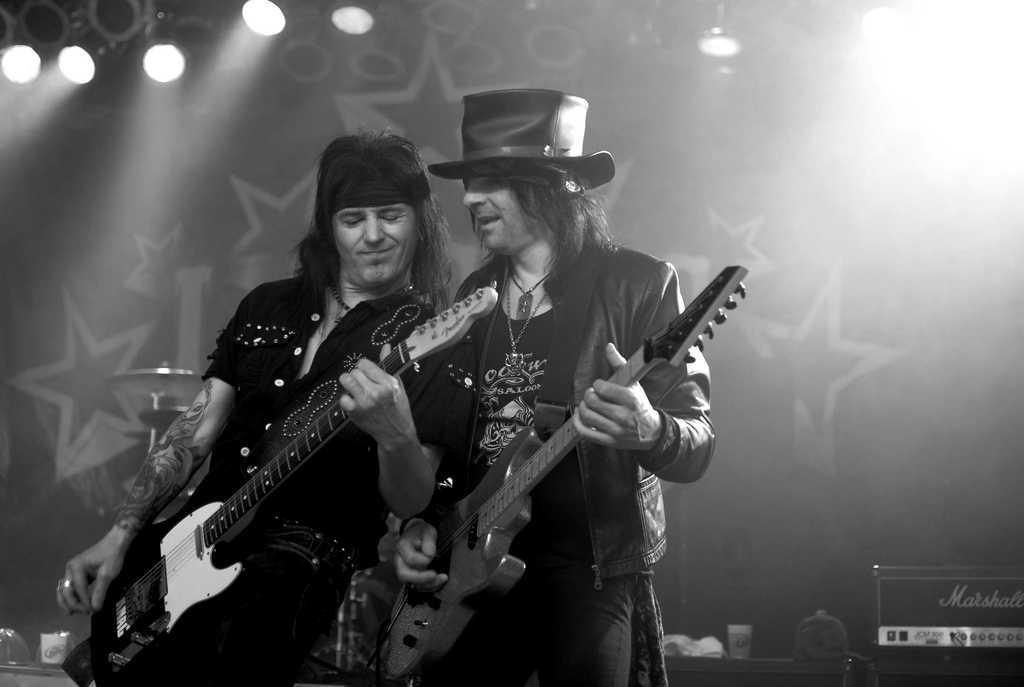Please provide a concise description of this image. In this image there are two persons standing and holding guitars , and at the background there are crash cymbals on the cymbal stand , glasses and some objects on the table, focus lights. 